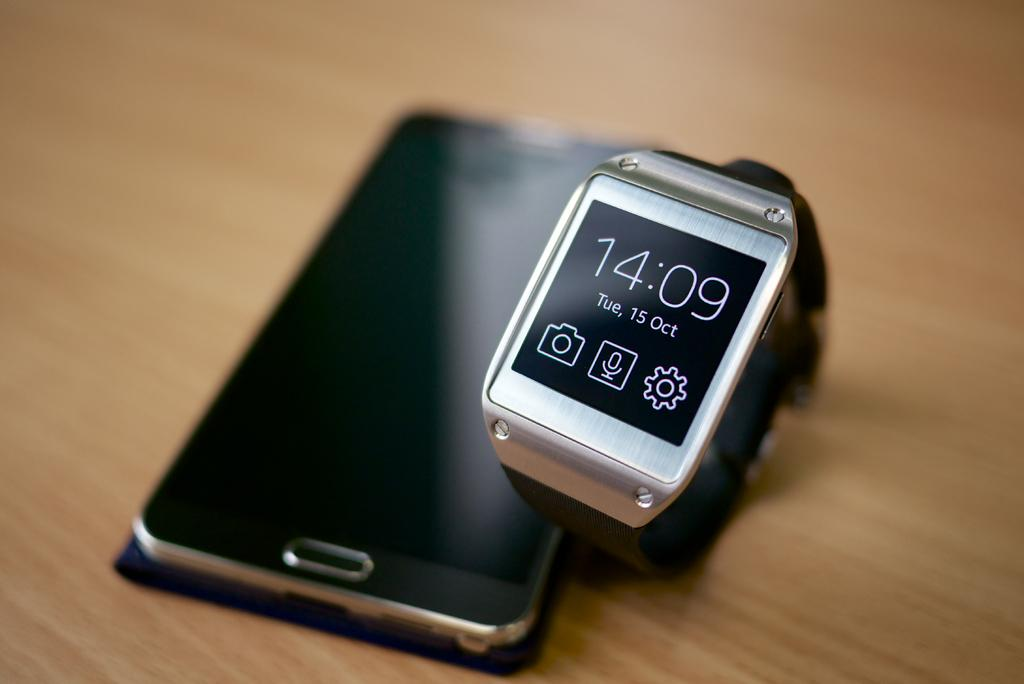<image>
Render a clear and concise summary of the photo. A black android phone is sitting next to a silver smart watch whose time reads 14:09 on its face. 